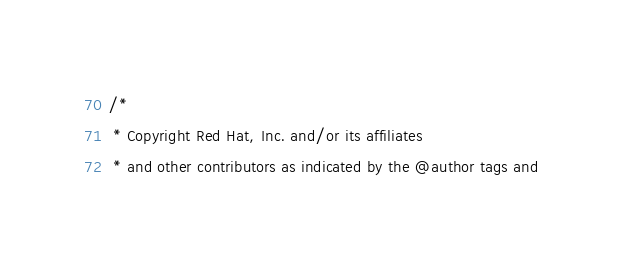<code> <loc_0><loc_0><loc_500><loc_500><_Java_>/*
 * Copyright Red Hat, Inc. and/or its affiliates
 * and other contributors as indicated by the @author tags and</code> 